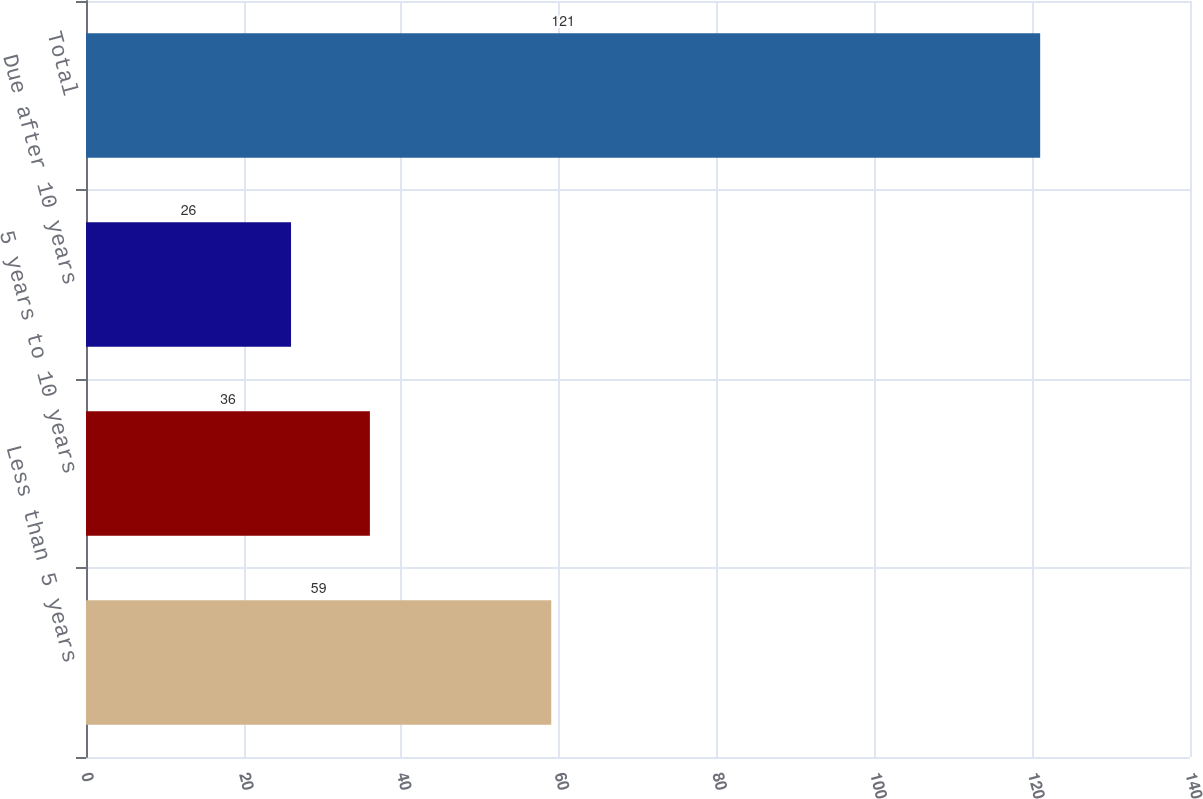<chart> <loc_0><loc_0><loc_500><loc_500><bar_chart><fcel>Less than 5 years<fcel>5 years to 10 years<fcel>Due after 10 years<fcel>Total<nl><fcel>59<fcel>36<fcel>26<fcel>121<nl></chart> 